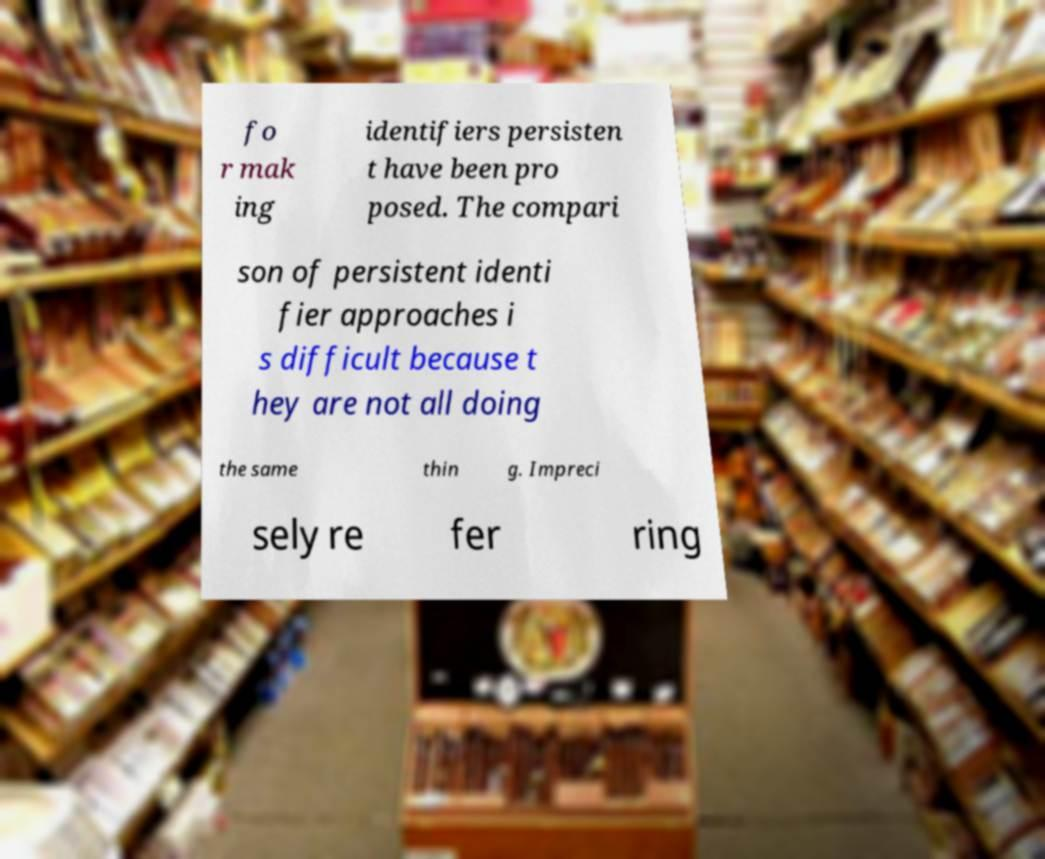There's text embedded in this image that I need extracted. Can you transcribe it verbatim? fo r mak ing identifiers persisten t have been pro posed. The compari son of persistent identi fier approaches i s difficult because t hey are not all doing the same thin g. Impreci sely re fer ring 